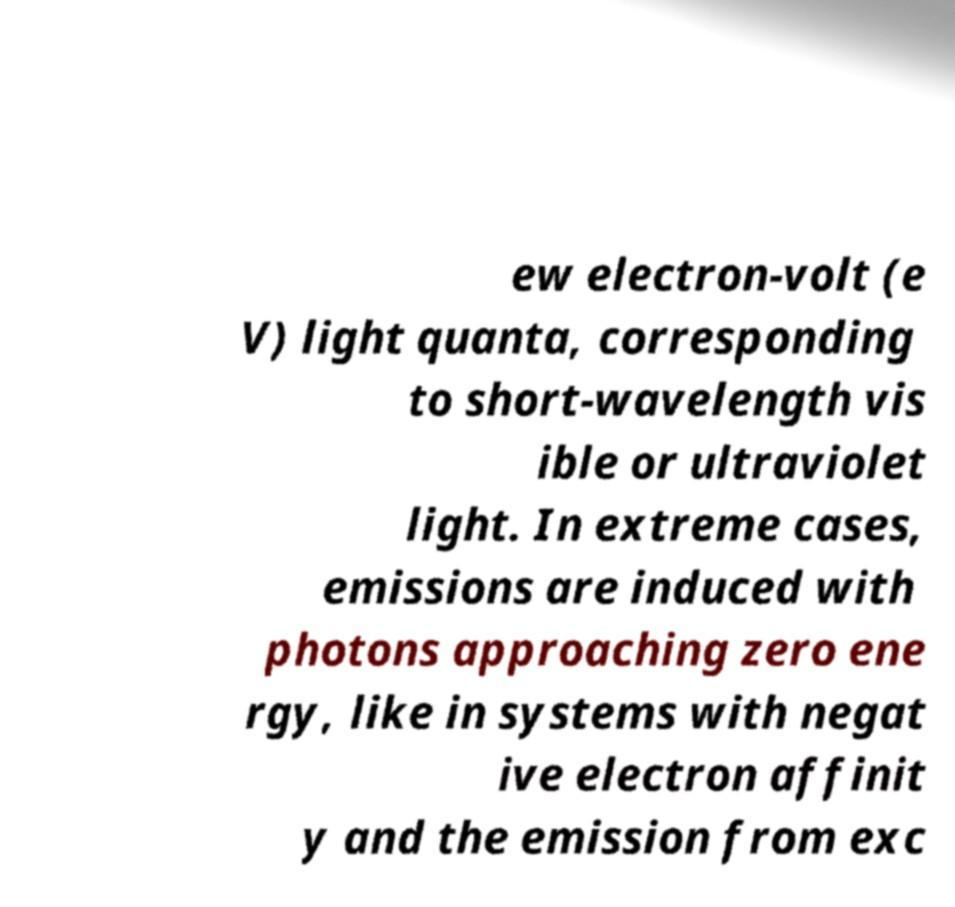There's text embedded in this image that I need extracted. Can you transcribe it verbatim? ew electron-volt (e V) light quanta, corresponding to short-wavelength vis ible or ultraviolet light. In extreme cases, emissions are induced with photons approaching zero ene rgy, like in systems with negat ive electron affinit y and the emission from exc 